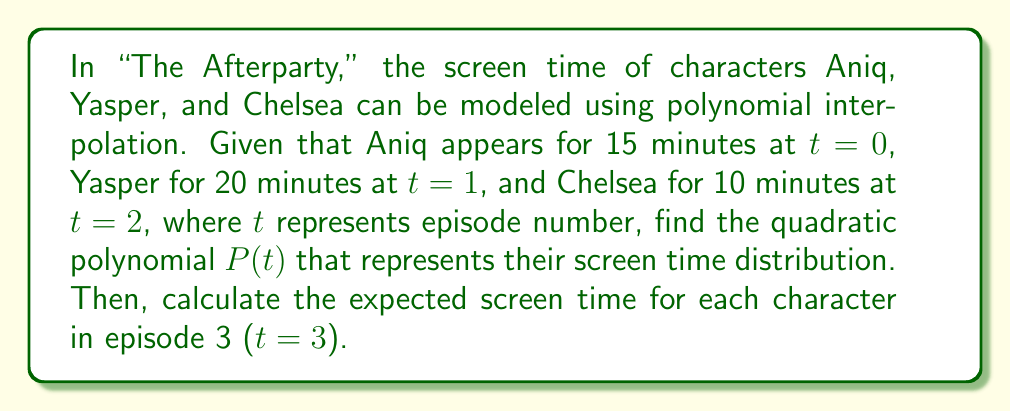Show me your answer to this math problem. To solve this problem, we'll use Lagrange interpolation to find the quadratic polynomial $P(t)$ that passes through the given points: (0,15), (1,20), and (2,10).

The Lagrange interpolation formula for a quadratic polynomial is:

$$P(t) = y_0L_0(t) + y_1L_1(t) + y_2L_2(t)$$

where:

$$L_0(t) = \frac{(t-1)(t-2)}{(0-1)(0-2)}$$
$$L_1(t) = \frac{(t-0)(t-2)}{(1-0)(1-2)}$$
$$L_2(t) = \frac{(t-0)(t-1)}{(2-0)(2-1)}$$

Substituting the values:

$$L_0(t) = \frac{(t-1)(t-2)}{(-1)(-2)} = \frac{t^2-3t+2}{2}$$
$$L_1(t) = \frac{(t-0)(t-2)}{(1)(-1)} = -(t^2-2t)$$
$$L_2(t) = \frac{(t-0)(t-1)}{(2)(1)} = \frac{t^2-t}{2}$$

Now, we can construct $P(t)$:

$$\begin{align}
P(t) &= 15 \cdot \frac{t^2-3t+2}{2} + 20 \cdot (-(t^2-2t)) + 10 \cdot \frac{t^2-t}{2} \\
&= \frac{15t^2-45t+30}{2} - 20t^2+40t + \frac{10t^2-10t}{2} \\
&= \frac{15t^2-45t+30-40t^2+80t+10t^2-10t}{2} \\
&= \frac{-15t^2+25t+30}{2} \\
&= -\frac{15}{2}t^2 + \frac{25}{2}t + 15
\end{align}$$

To find the expected screen time for each character in episode 3, we evaluate $P(3)$:

$$\begin{align}
P(3) &= -\frac{15}{2}(3)^2 + \frac{25}{2}(3) + 15 \\
&= -\frac{15}{2}(9) + \frac{75}{2} + 15 \\
&= -\frac{135}{2} + \frac{75}{2} + 15 \\
&= -30 + 15 \\
&= -15
\end{align}$$
Answer: The quadratic polynomial representing the screen time distribution is:

$$P(t) = -\frac{15}{2}t^2 + \frac{25}{2}t + 15$$

The expected screen time for each character in episode 3 (t=3) is -15 minutes. However, since negative screen time is not possible in reality, this result suggests that the quadratic model may not be suitable for extrapolation beyond the given data points. 